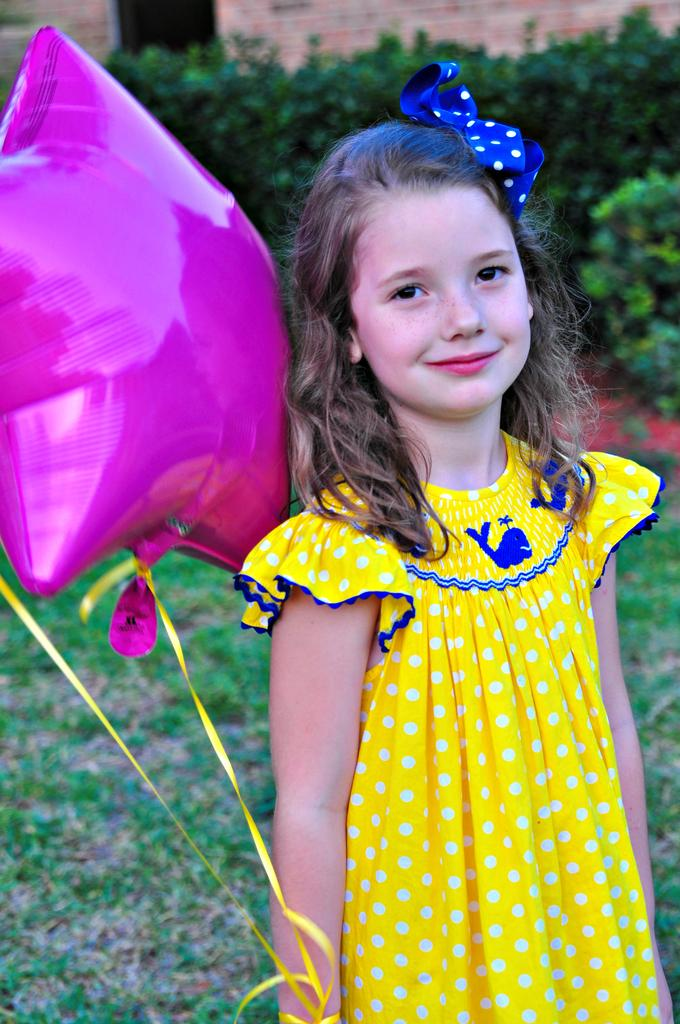What is the main subject of the image? The main subject of the image is a kid. What is the kid doing in the image? The kid is smiling in the image. What is the kid wearing in the image? The kid is wearing a ribbon in the image. What is the kid holding in the image? The kid is holding a balloon in the image. What can be seen in the background of the image? There are trees and a wall visible in the background of the image. What is visible at the bottom of the image? There is a ground visible at the bottom of the image. What type of patch is sewn onto the kid's clothing in the image? There is no patch visible on the kid's clothing in the image. What year is depicted in the image? The image does not depict a specific year; it is a snapshot of a moment in time. 